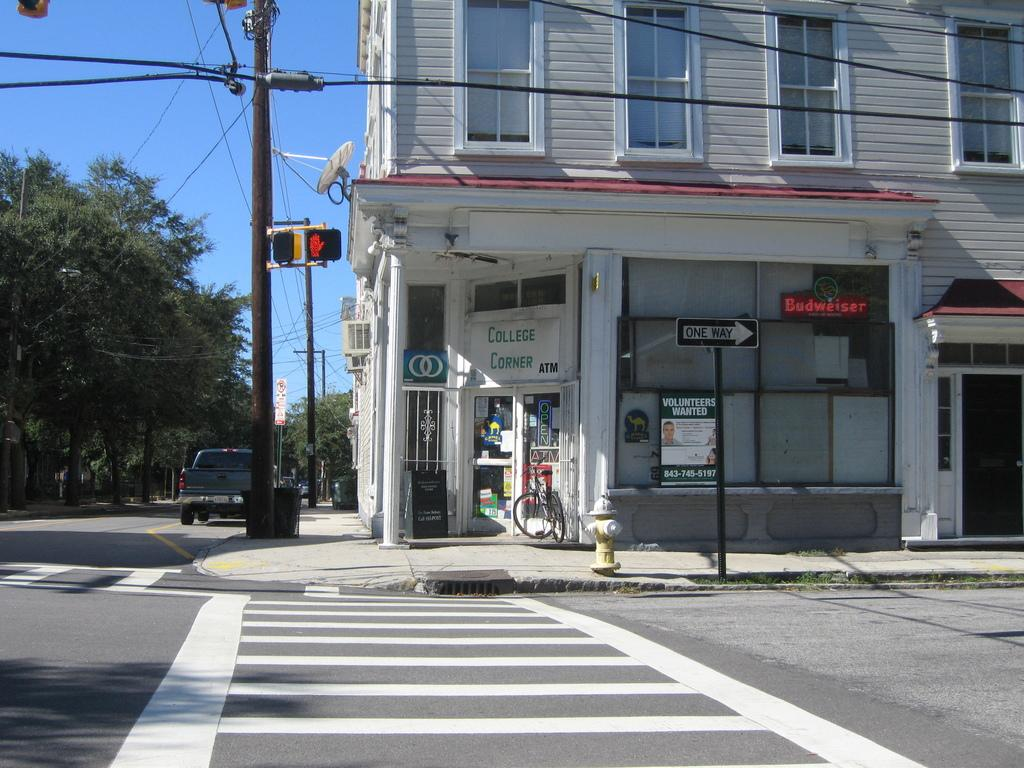<image>
Give a short and clear explanation of the subsequent image. The shop located at this road intersection is called College Corner 